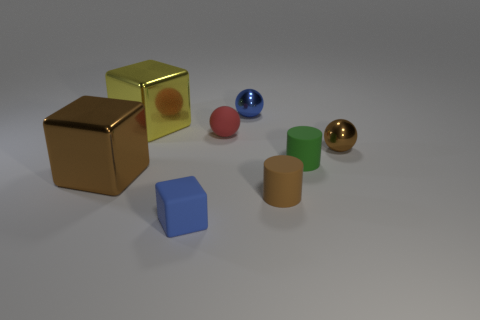How many things are small blue things behind the tiny red rubber object or small spheres?
Offer a very short reply. 3. The red object that is the same material as the tiny brown cylinder is what shape?
Your answer should be compact. Sphere. What is the shape of the small green thing?
Your answer should be very brief. Cylinder. There is a small rubber thing that is to the right of the tiny blue matte cube and to the left of the tiny blue ball; what color is it?
Provide a short and direct response. Red. What is the shape of the brown rubber thing that is the same size as the blue rubber block?
Provide a succinct answer. Cylinder. Are there any cyan rubber objects of the same shape as the red object?
Provide a short and direct response. No. Is the material of the brown cylinder the same as the brown thing that is left of the small blue rubber block?
Offer a terse response. No. There is a metallic block in front of the metallic block that is behind the metallic sphere that is to the right of the brown cylinder; what is its color?
Offer a very short reply. Brown. What material is the blue ball that is the same size as the matte cube?
Offer a terse response. Metal. How many big yellow cylinders have the same material as the large brown thing?
Provide a succinct answer. 0. 